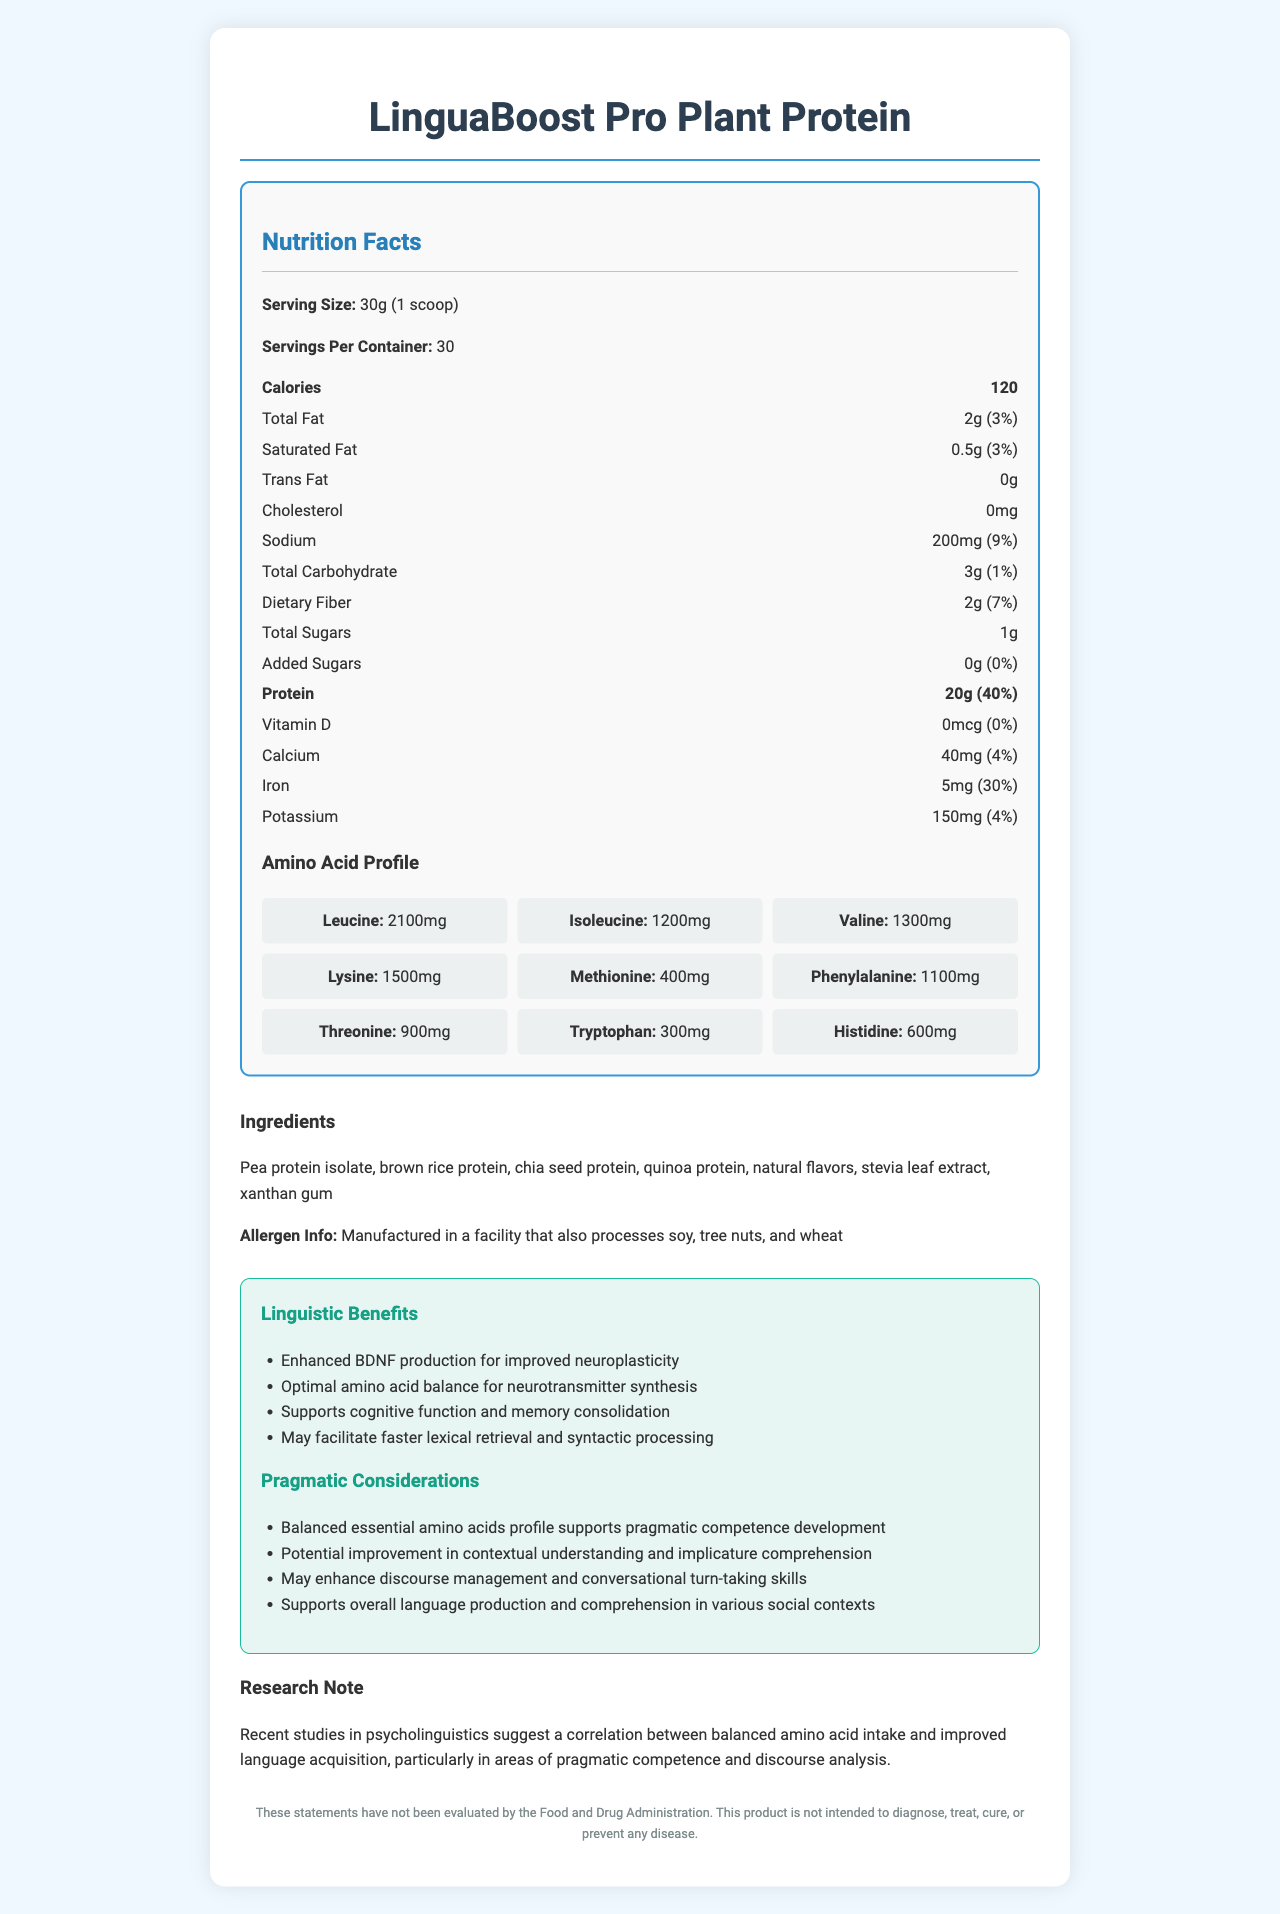what is the serving size? The serving size is clearly mentioned near the top of the nutrition facts section as "Serving Size: 30g (1 scoop)".
Answer: 30g (1 scoop) what are the main ingredients in LinguaBoost Pro Plant Protein? This information is listed under the "Ingredients" section of the document.
Answer: Pea protein isolate, brown rice protein, chia seed protein, quinoa protein, natural flavors, stevia leaf extract, xanthan gum how many calories are in each serving? The number of calories per serving is clearly listed as "Calories: 120" in the nutrition facts section.
Answer: 120 which amino acid is present in the largest amount per serving? The amino acid profile section lists leucine as having the highest amount with 2100mg per serving.
Answer: Leucine how much iron is there per serving, and what is its daily value percentage? The document lists iron content as 5mg per serving and the daily value as 30% in the nutrition facts section.
Answer: 5mg, 30% what are some potential pragmatic benefits of consuming LinguaBoost Pro Plant Protein? This information is provided under the "Pragmatic Considerations" heading in the benefits section.
Answer: Enhanced contextual understanding, improved implicature comprehension, better discourse management, and conversational turn-taking skills what is the main idea of this document? The document combines nutritional information with potential cognitive and linguistic benefits, catering specifically to language acquisition and pragmatic competence.
Answer: This document is a detailed nutrition facts label for LinguaBoost Pro Plant Protein, highlighting its nutritional content, amino acid profile, ingredients, linguistic and pragmatic benefits, and a research note on the correlation between amino acid intake and language acquisition. which of the following is a benefit mentioned for neuroplasticity? A. Improved cholesterol levels B. Enhanced BDNF production C. Increased dietary fiber D. Lower calories The document lists "Enhanced BDNF production for improved neuroplasticity" under the "Linguistic Benefits" section.
Answer: B how many servings are in one container of LinguaBoost Pro Plant Protein? A. 20 B. 25 C. 30 D. 35 The document mentions "Servings Per Container: 30" under the nutrition facts heading, so the answer is 30.
Answer: C is there any added sugar in this protein powder? The document lists "Added Sugars: 0g (0%)" which indicates that there is no added sugar in the product.
Answer: No what is the total fat content per serving, and what percentage of the daily value does it represent? The total fat content is listed as "Total Fat: 2g (3%)" in the nutrition facts section of the document.
Answer: 2g, 3% which amino acid profile component has the lowest quantity, and how much is it? Under the amino acid profile, tryptophan is listed as having 300mg per serving, which is the lowest quantity among the amino acids listed.
Answer: Tryptophan, 300mg what type of research study is referenced in the document in relation to amino acid intake and language acquisition? The document mentions a "research note" indicating studies in psycholinguistics have found a correlation between balanced amino acid intake and improved language acquisition.
Answer: Psycholinguistics how does LinguaBoost Pro Plant Protein support cognitive function and memory consolidation? This is listed under the "Linguistic Benefits" section, mentioning "Optimal amino acid balance for neurotransmitter synthesis" which supports cognitive function and memory consolidation.
Answer: Through optimal amino acid balance for neurotransmitter synthesis does LinguaBoost Pro Plant Protein help with cholesterol management? The document does not provide information about the product's effectiveness in cholesterol management.
Answer: Cannot be determined What are the daily value percentages for potassium and calcium per serving? The document lists these daily values in the nutrition facts section as Potassium: 150mg (4%) and Calcium: 40mg (4%).
Answer: Potassium: 4%, Calcium: 4% 